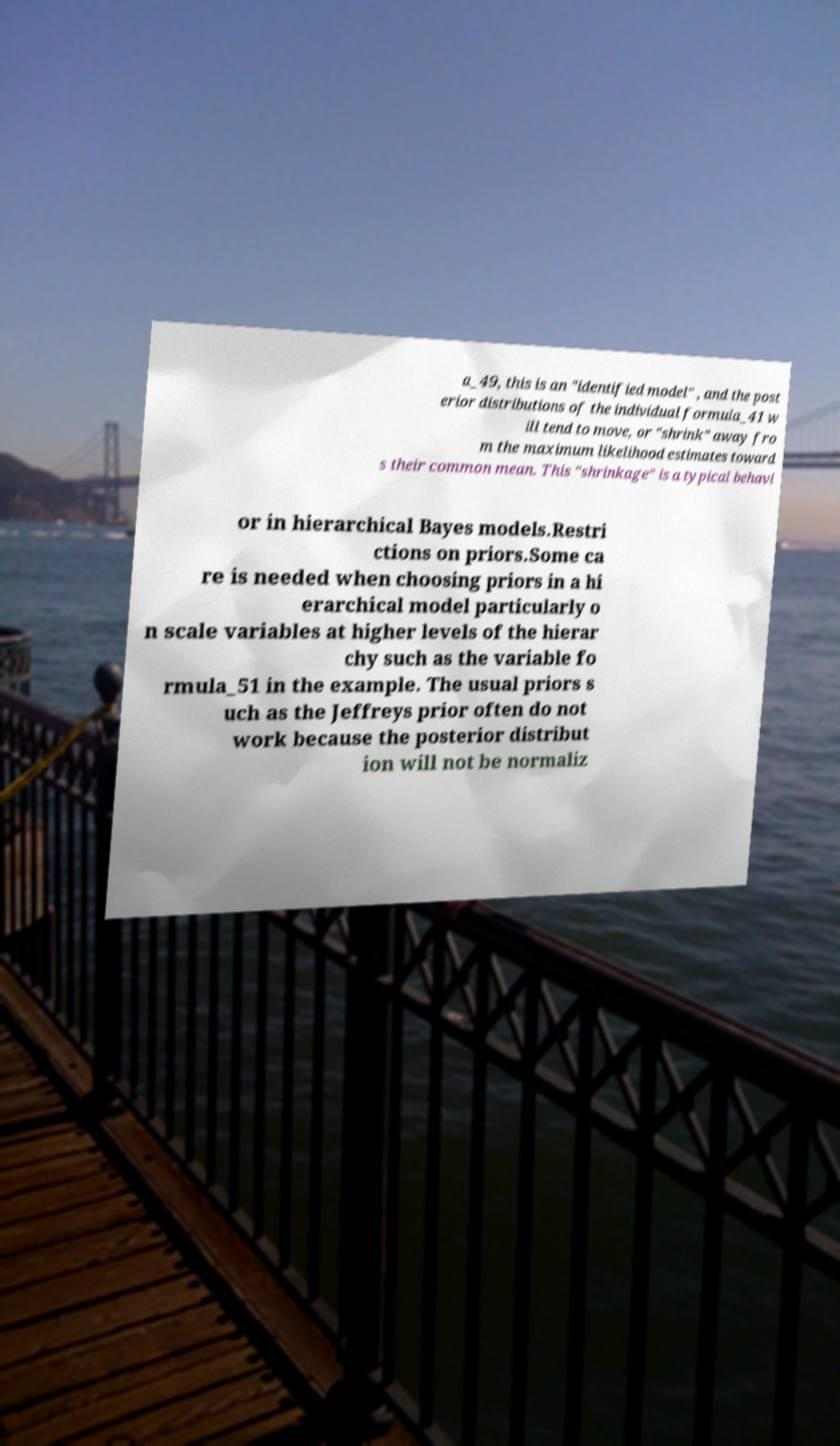There's text embedded in this image that I need extracted. Can you transcribe it verbatim? a_49, this is an "identified model" , and the post erior distributions of the individual formula_41 w ill tend to move, or "shrink" away fro m the maximum likelihood estimates toward s their common mean. This "shrinkage" is a typical behavi or in hierarchical Bayes models.Restri ctions on priors.Some ca re is needed when choosing priors in a hi erarchical model particularly o n scale variables at higher levels of the hierar chy such as the variable fo rmula_51 in the example. The usual priors s uch as the Jeffreys prior often do not work because the posterior distribut ion will not be normaliz 